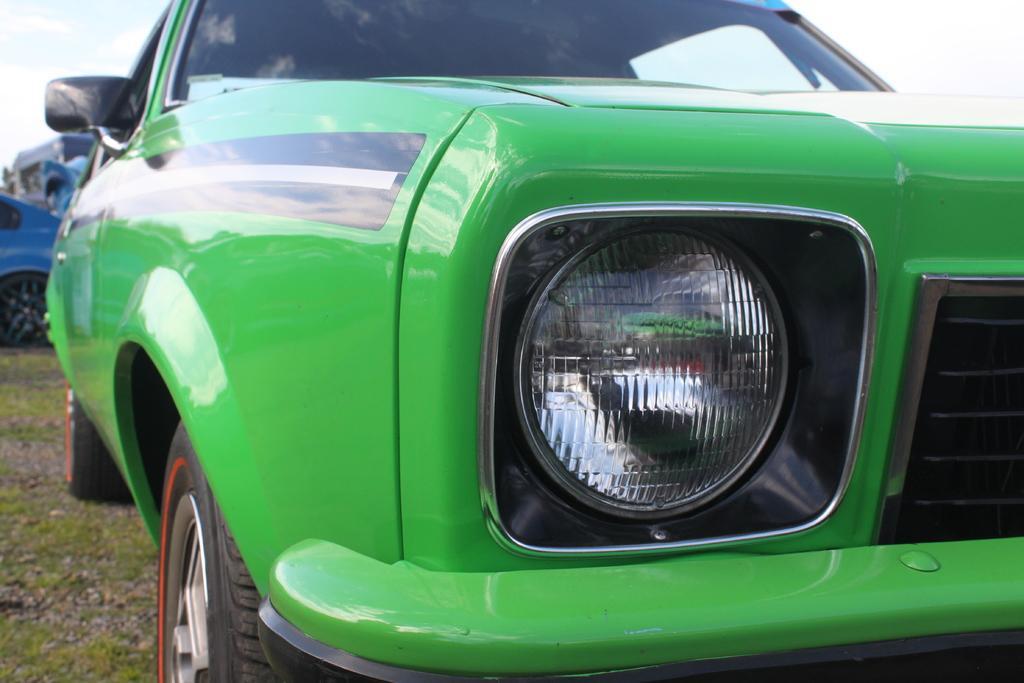In one or two sentences, can you explain what this image depicts? This image is taken outdoors. At the top of the image there is a sky with clouds. In the background a few vehicles are parked on the ground. At the bottom of the image there is a ground with grass on it. In the middle of the image a car is parked on the ground. The car is green in color. 